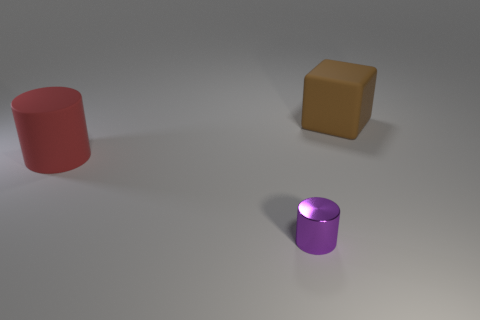Add 2 brown objects. How many objects exist? 5 Subtract all purple cylinders. How many cylinders are left? 1 Subtract all cubes. How many objects are left? 2 Add 1 big cylinders. How many big cylinders are left? 2 Add 1 large blue rubber balls. How many large blue rubber balls exist? 1 Subtract 1 brown cubes. How many objects are left? 2 Subtract 2 cylinders. How many cylinders are left? 0 Subtract all gray blocks. Subtract all cyan cylinders. How many blocks are left? 1 Subtract all small gray metal cylinders. Subtract all red things. How many objects are left? 2 